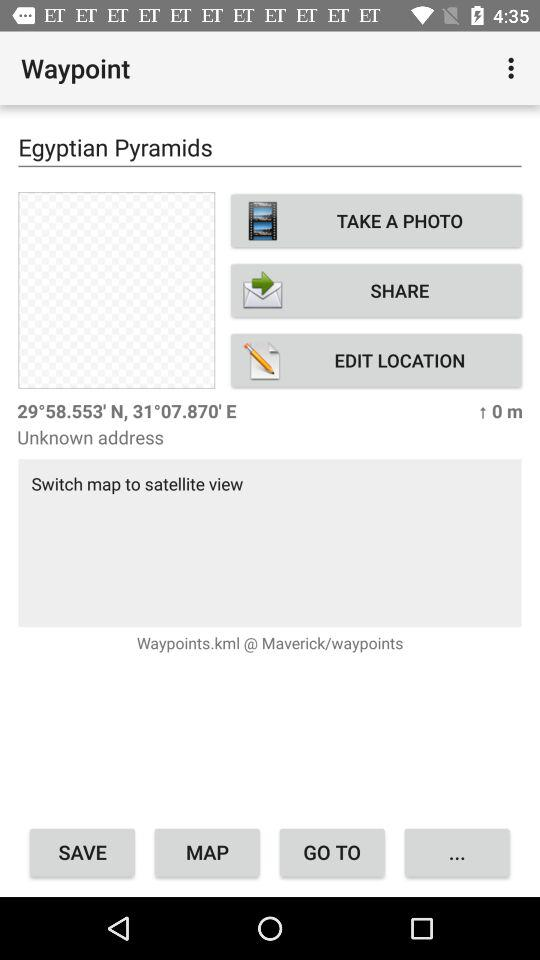What is the location? The location is the Egyptian Pyramids. 